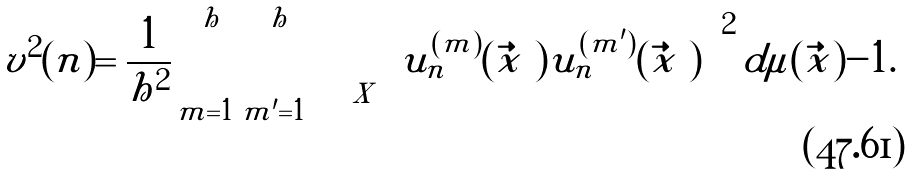Convert formula to latex. <formula><loc_0><loc_0><loc_500><loc_500>v ^ { 2 } ( n ) = \frac { 1 } { h ^ { 2 } } \sum _ { m = 1 } ^ { h } \sum _ { m ^ { \prime } = 1 } ^ { h } \int _ { X } \left [ u _ { n } ^ { ( m ) } ( \vec { x } \ ) u _ { n } ^ { ( m ^ { \prime } ) } ( \vec { x } \ ) \right ] ^ { 2 } d \mu ( \vec { x } ) - 1 .</formula> 